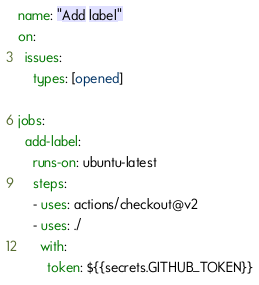<code> <loc_0><loc_0><loc_500><loc_500><_YAML_>name: "Add label"
on:
  issues:
    types: [opened]

jobs:
  add-label:
    runs-on: ubuntu-latest
    steps:
    - uses: actions/checkout@v2
    - uses: ./
      with:
        token: ${{secrets.GITHUB_TOKEN}}
</code> 